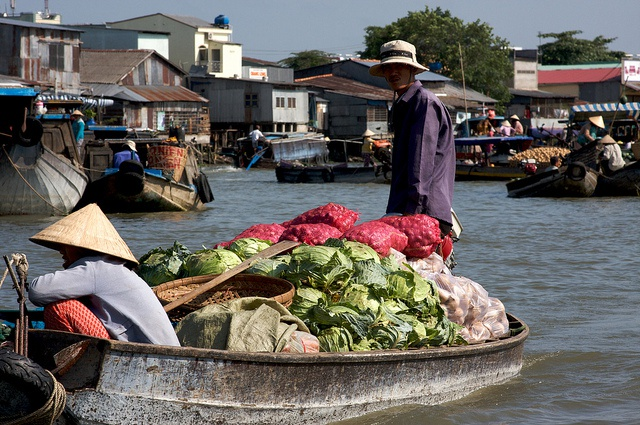Describe the objects in this image and their specific colors. I can see boat in darkgray, black, and gray tones, people in darkgray, lightgray, and black tones, people in darkgray, black, gray, and ivory tones, boat in darkgray, black, and gray tones, and boat in darkgray, black, tan, and gray tones in this image. 